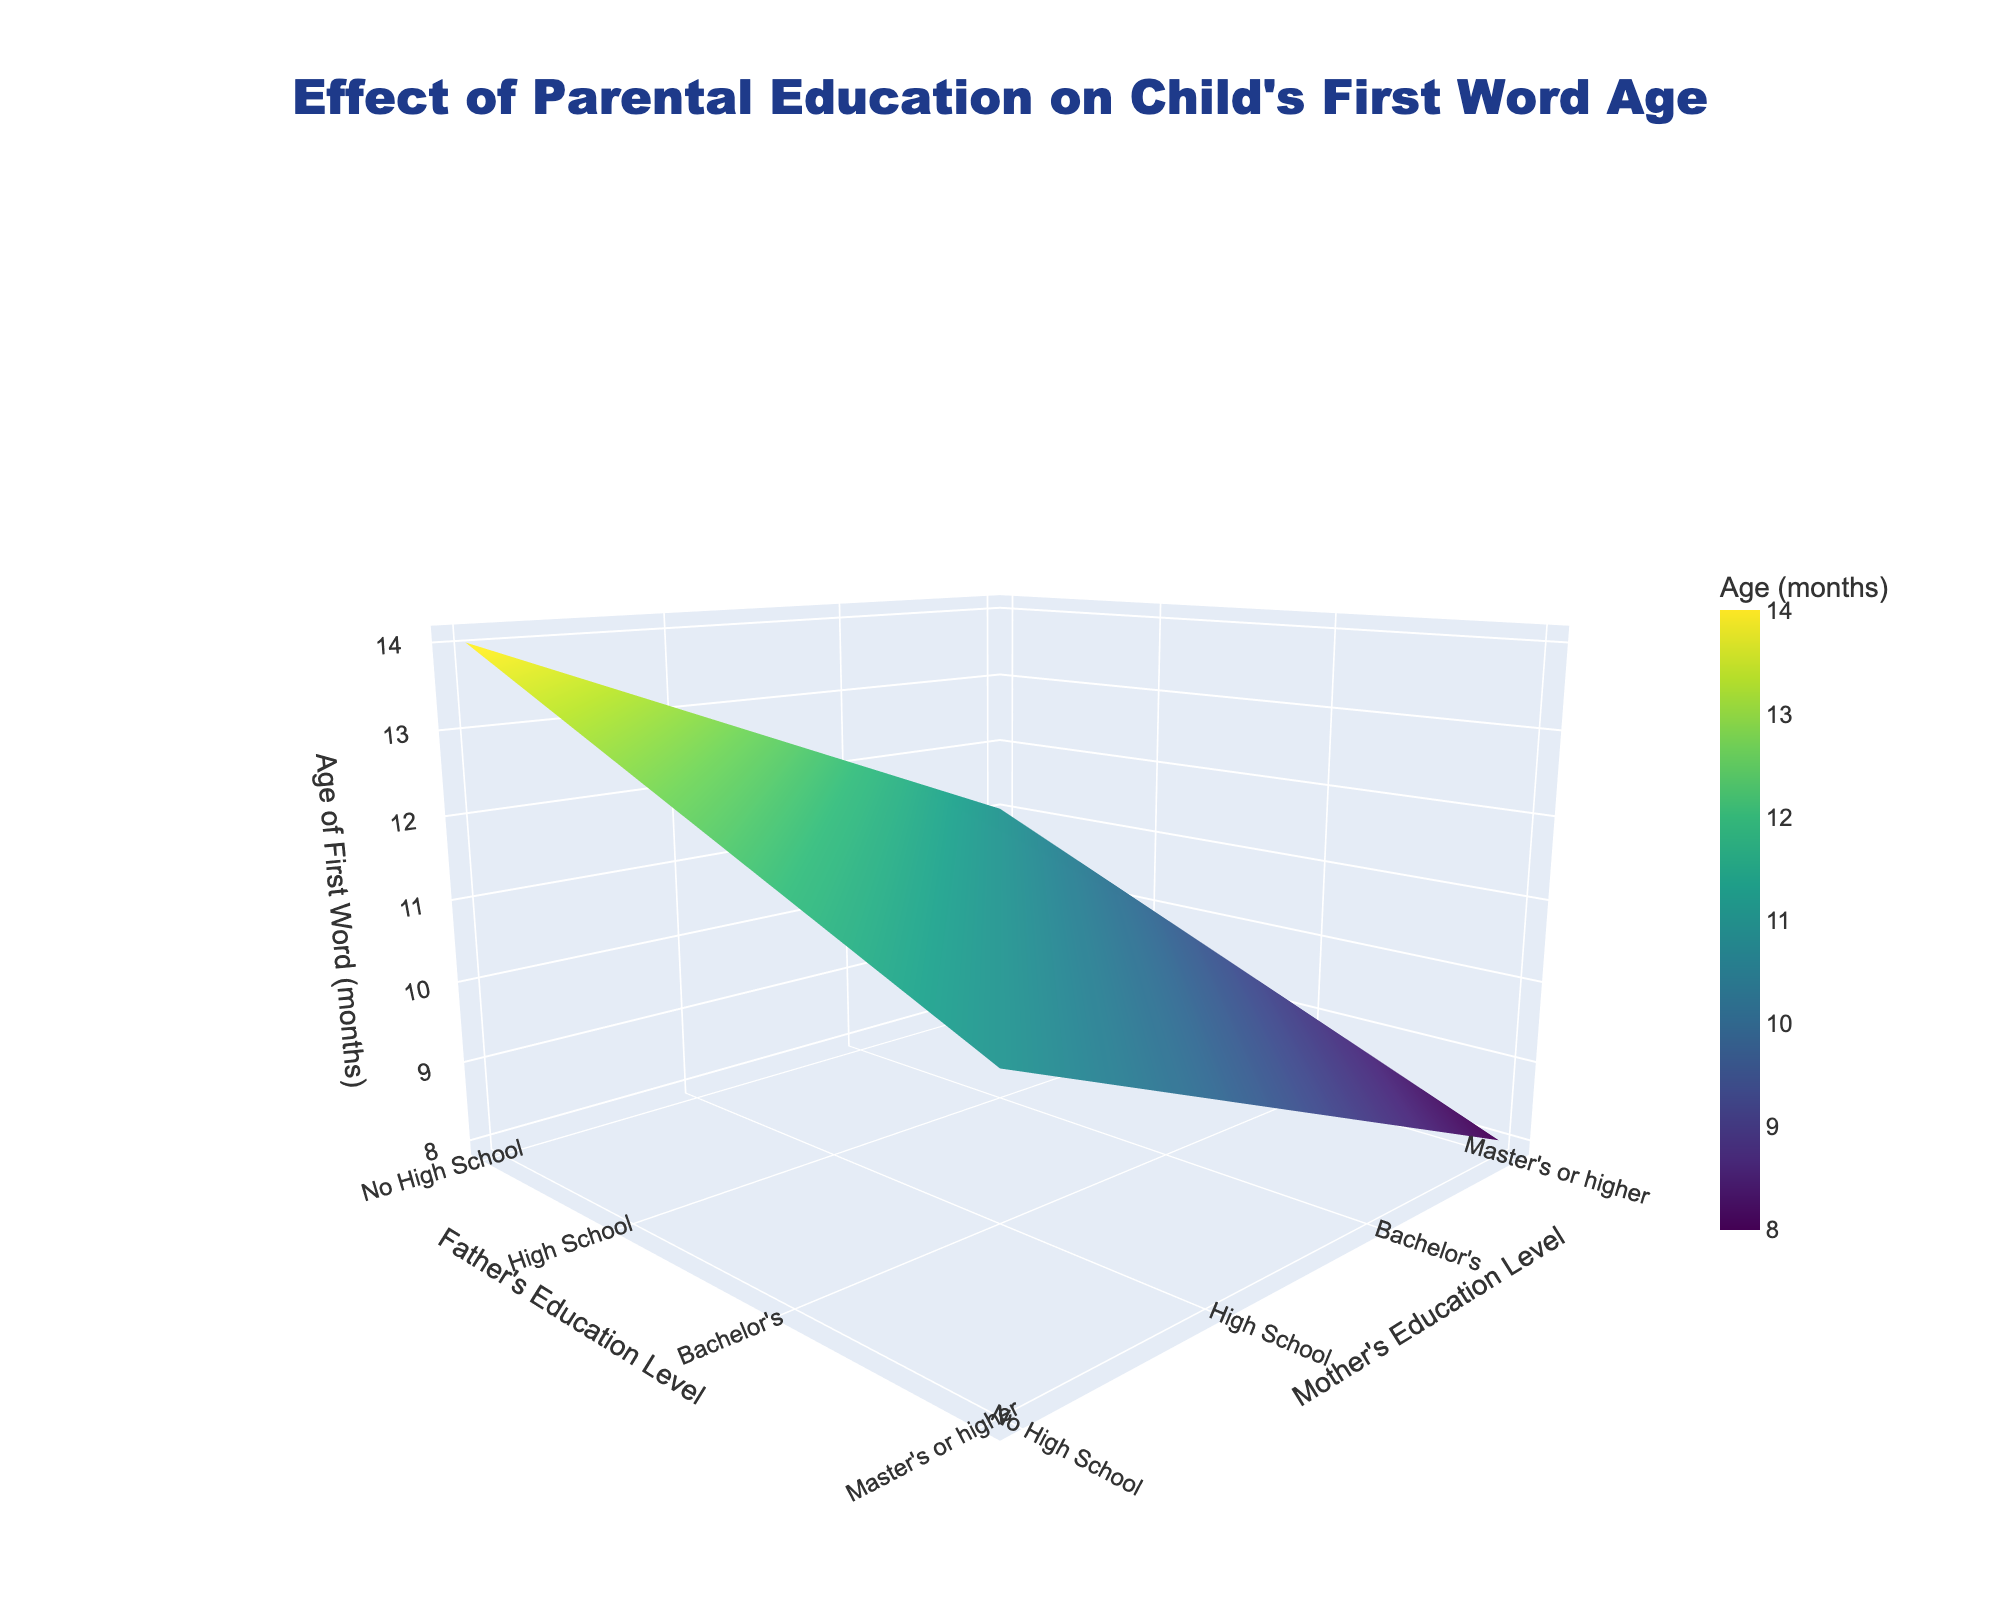What is the title of the figure? The title can be found at the top of the plot. The large font size and centered alignment make it prominent.
Answer: Effect of Parental Education on Child's First Word Age What are the axis titles for the plot? The axis titles are located next to each axis in the plot. The x-axis title is at the bottom, the y-axis title on the left side, and the z-axis title along the vertical axis.
Answer: Father's Education Level; Mother's Education Level; Age of First Word (months) Which combination of parental education levels corresponds to the youngest average age for a child to say their first word? To find this, look for the lowest z-value on the plot. The coordinates where this occurs will give the combination of parental education levels.
Answer: Mother's: Master's or higher; Father's: Master's or higher How does the average age of first word change as both parents’ education levels increase from 'No High School' to 'Master's or higher'? Look at the plot slope from the lower-left corner (No High School) up to the top-right corner (Master's or higher) on both axes. Note that the z-value decreases as you move towards this region.
Answer: It decreases Is there a difference in the average age of first word between children whose mothers have a Bachelor's degree and children whose fathers have a Bachelor's degree? Compare the plot values along the lines where the mother's education level and father's education level are marked as Bachelor's respectively. Check if those z-values are equal or indicate a trend.
Answer: Yes, higher maternal education tends to be associated with younger first word age Among parents with 'High School' education, is there a difference in children's average first word age based on the father's education level? Examine the row in the plot where the mother's education level is 'High School'. Compare the values across different father's education levels.
Answer: Yes, different father's education levels show a gradual decrease in first word age What's the effect of the father's education level on children's first word age when the mother's education level is 'No High School'? Look at the row in the plot where the mother's education level is 'No High School'. Notice how the z-values change as you move across different father's education levels.
Answer: Higher father's education level reduces the age of the first word Which parental education combination results in the oldest average age for a child's first word? Identify the highest z-value on the plot. Determine the coordinates of this data point which indicates the educational levels of both parents.
Answer: Mother's: No High School; Father's: No High School How does the average age of first word change when only the mother's education level changes and the father's remains constant at 'Bachelor’s'? Look for the column where the father's education level is 'Bachelor’s'. Note the changes in the z-values as the mother’s education level varies from 'No High School' to 'Master's or higher'.
Answer: It decreases 